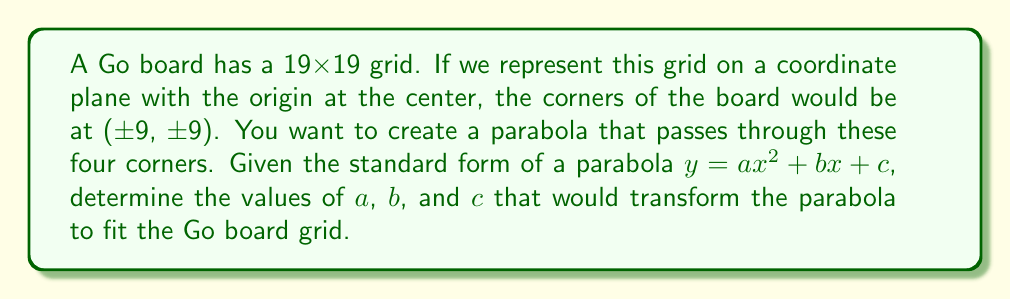Give your solution to this math problem. Let's approach this step-by-step:

1) We know the parabola needs to pass through the points (9, 9), (9, -9), (-9, 9), and (-9, -9).

2) Due to the symmetry of these points, we can deduce that $b = 0$ (the parabola is symmetric about the y-axis).

3) We can use the point (9, 9) to set up our equation:

   $9 = a(9^2) + c$

4) Simplify:

   $9 = 81a + c$

5) We can use the point (9, -9) to set up another equation:

   $-9 = a(9^2) + c$

6) Simplify:

   $-9 = 81a + c$

7) Subtracting equation 6 from equation 4:

   $18 = 0$

   This confirms our equations are consistent.

8) We can solve for $c$ in terms of $a$:

   $c = 9 - 81a$

9) Substitute this into either equation:

   $9 = 81a + (9 - 81a)$
   $9 = 9$

   This is true for any value of $a$.

10) To determine $a$, we can use the fact that the parabola should open upwards and pass through (-9, 9):

    $9 = a(-9^2) + (9 - 81a)$
    $9 = 81a + 9 - 81a$
    $0 = 0$

11) This means any positive value of $a$ will work. For simplicity, let's choose $a = \frac{1}{81}$.

12) Then $c = 9 - 81(\frac{1}{81}) = 8$.

Therefore, the equation of the parabola is $y = \frac{1}{81}x^2 + 8$.
Answer: $a = \frac{1}{81}$, $b = 0$, $c = 8$ 